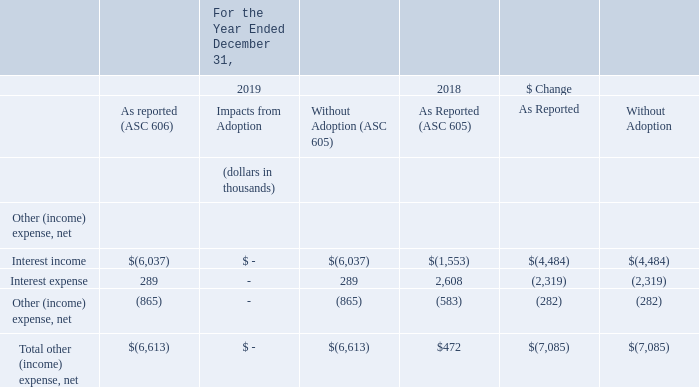Total Other (Income) Expense, Net
Total other income for the year ended December 31, 2019 was $6.6 million compared to $0.5 million of other expense for the year ended December 31,
2018. Interest income increased due to interest earned on investing our public offering cash proceeds. Interest expense decreased due to having no outstanding borrowings during the year ended December 31, 2019. We discuss borrowings under “Liquidity and Capital Resources” below. Other (income) expense, net was $0.9 million other income in the year ended December 31, 2019 compared to $0.6 million of other income in the year ended December 31, 2018, primarily due to our earnout liabilities. We estimate the fair value of earnout liabilities related to business combinations quarterly. During the year ended December 31, 2019, the adjustments to fair value decreased the carrying value of the earnout liability for our acquisition of Indix, resulting in other income of $1.7 million, partially offset by an increase in the carrying value of the earnout liabilities for our acquisitions of Compli and Portway, which resulted in other expense of $0.6 million. The fair value of the Indix acquisition earnout liability decreased at December 31, 2019, from the fair value at acquisition in February 2019, due primarily to the last three earnout milestones, which are nonfinancial, being more difficult to complete within the required timeframe than initially assessed. During the year ended December 31, 2018, the adjustments to fair value decreased the carrying value of the earnout liabilities for prior acquisitions, resulting in other income of $0.4 million.
What are the total income for the year ended December 31, 2019 and the other expense for the year ended December 31, 2018 respectively? $6.6 million, $0.5 million. What caused the increase in interest income and decrease in interest expense for the year ended 31 December 2019 respectively? Interest earned on investing our public offering cash proceeds, having no outstanding borrowings during the year. What are the net other (income) expense for the years ended December 31, 2019 and 2018 respectively? $0.9 million, $0.6 million. What is the percentage change in net other (income) expenses between 2018 and 2019?
Answer scale should be: percent. (0.9 - 0.6)/0.6 
Answer: 50. What is the difference in the company's total other (income) expense in 2019 under ASC 606 and ASC 605?
Answer scale should be: thousand. -6,613 - (-6,613) 
Answer: 0. What is the value of the 2018 as reported value as a percentage of the 2019 as reported value of total net other (income) expense?
Answer scale should be: percent. 472/-6,613 
Answer: -7.14. 